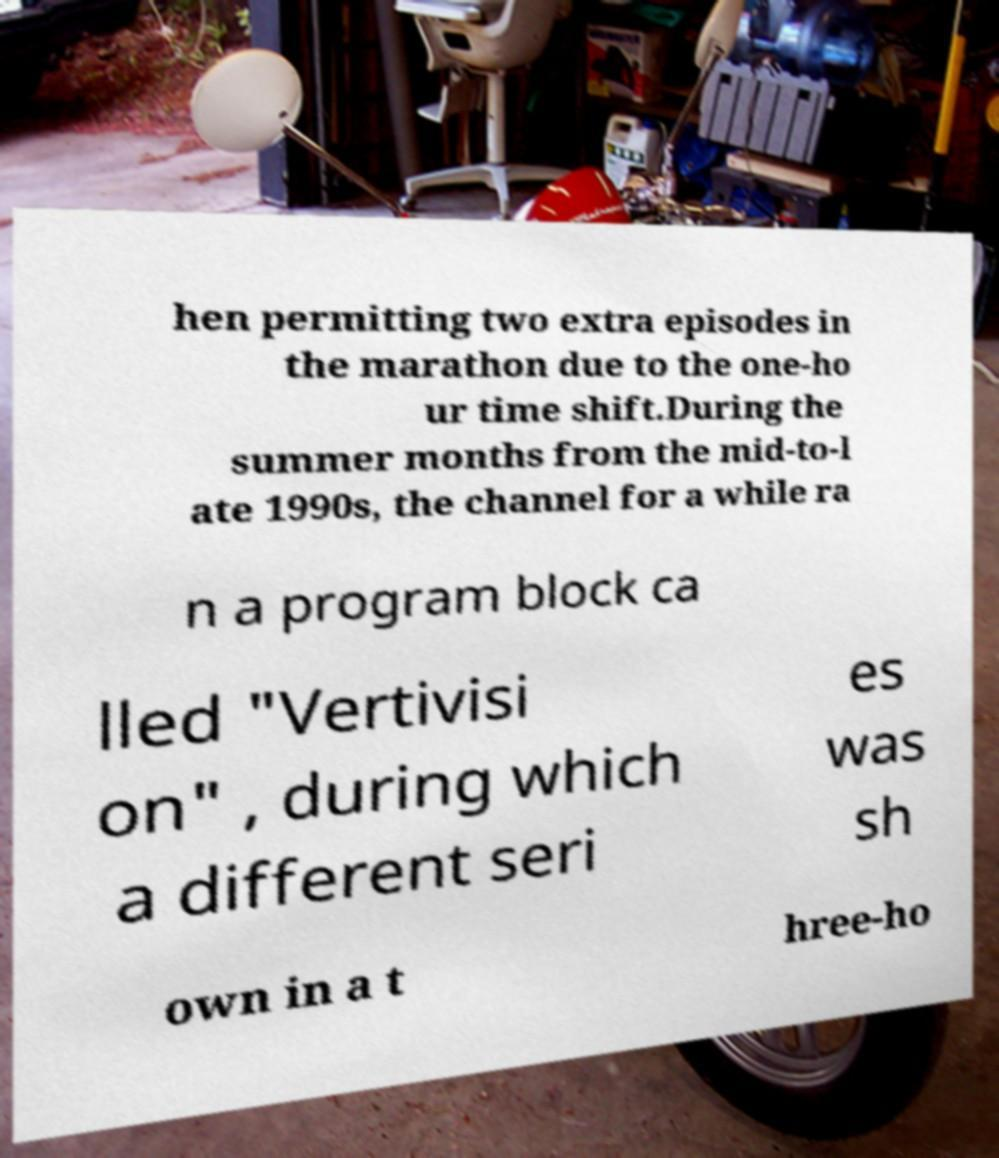What messages or text are displayed in this image? I need them in a readable, typed format. hen permitting two extra episodes in the marathon due to the one-ho ur time shift.During the summer months from the mid-to-l ate 1990s, the channel for a while ra n a program block ca lled "Vertivisi on" , during which a different seri es was sh own in a t hree-ho 